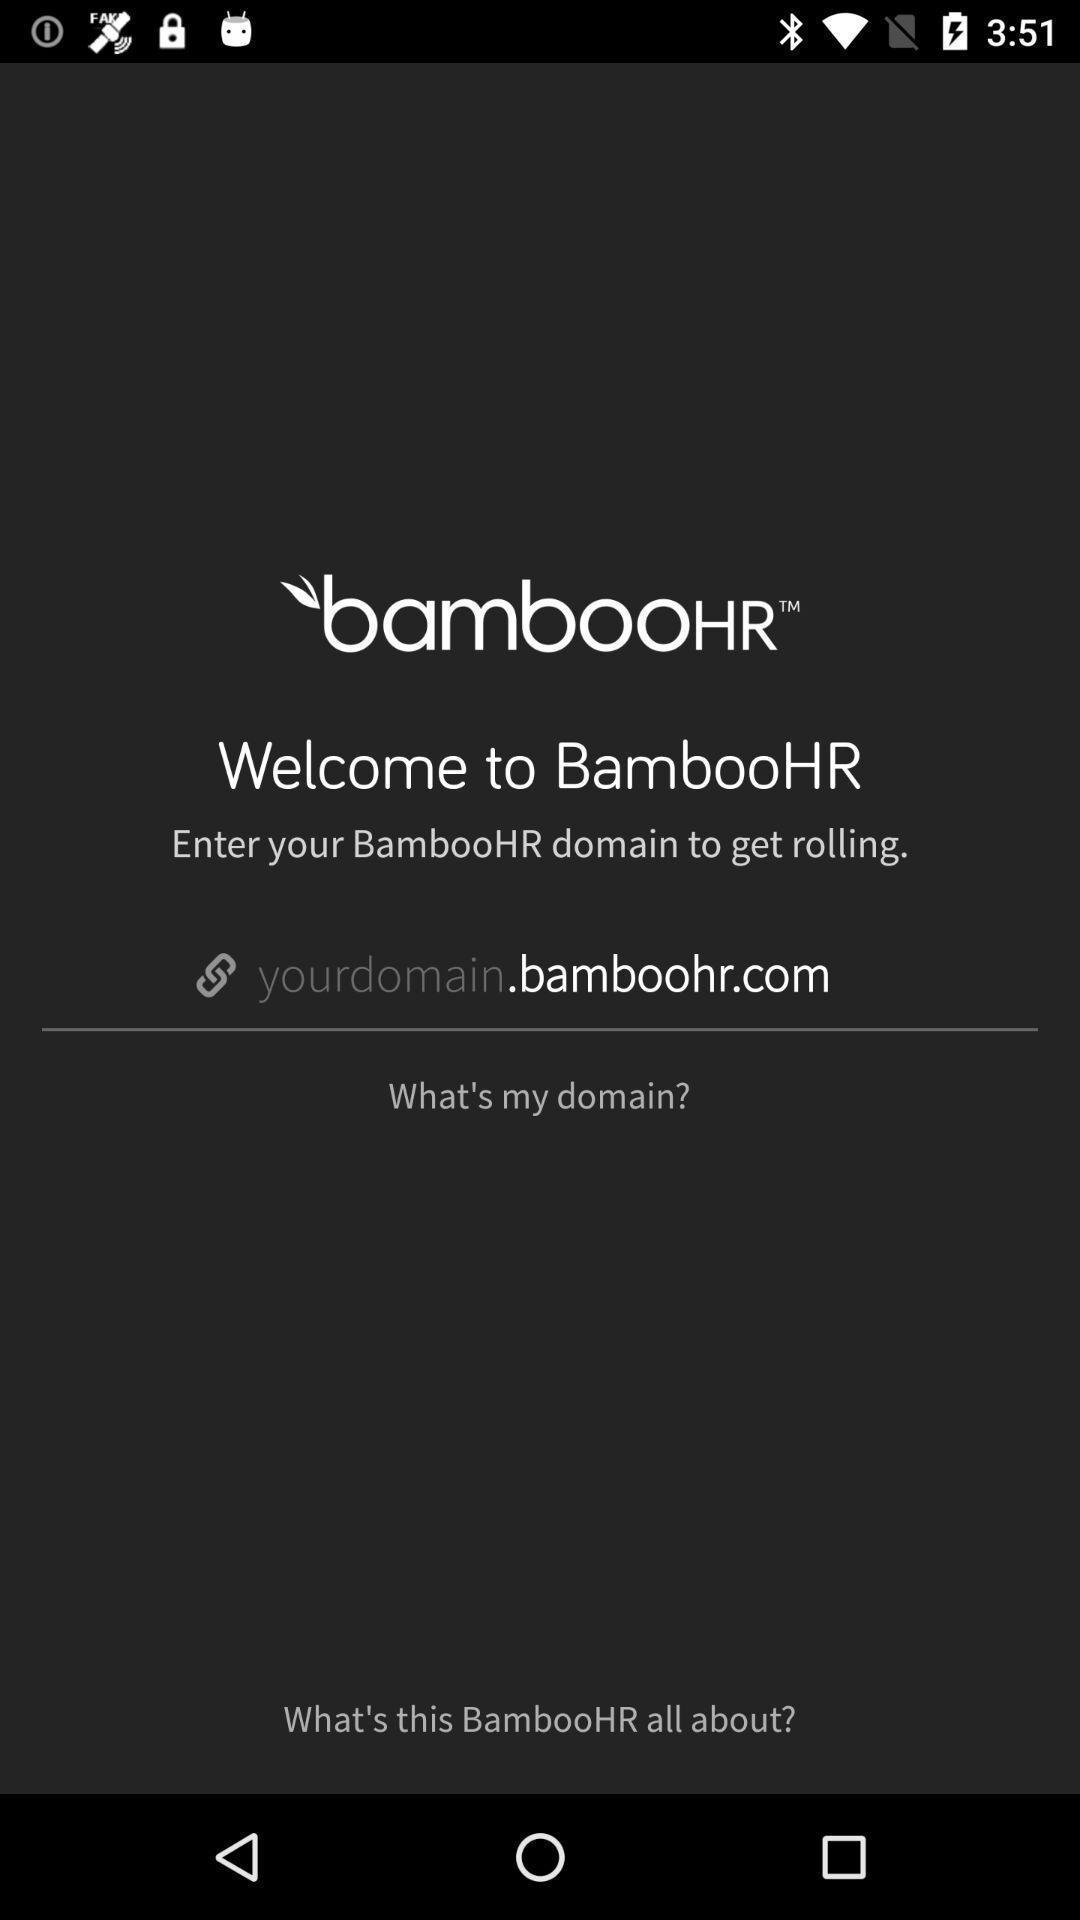Describe the content in this image. Welcome page. 